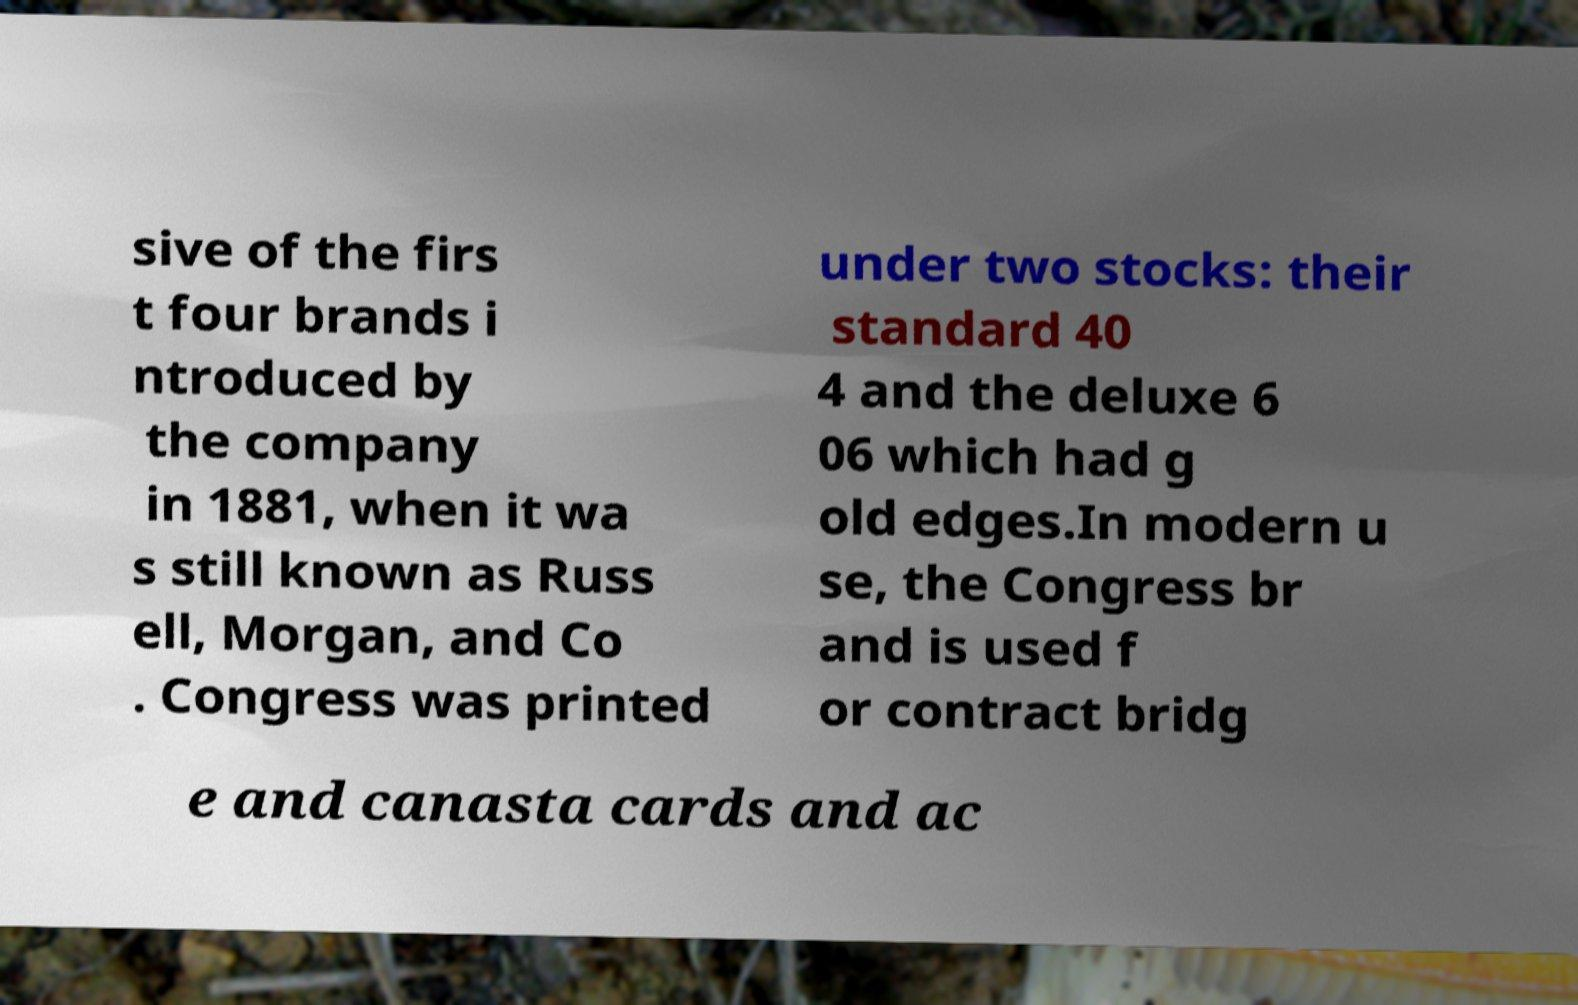Please read and relay the text visible in this image. What does it say? sive of the firs t four brands i ntroduced by the company in 1881, when it wa s still known as Russ ell, Morgan, and Co . Congress was printed under two stocks: their standard 40 4 and the deluxe 6 06 which had g old edges.In modern u se, the Congress br and is used f or contract bridg e and canasta cards and ac 